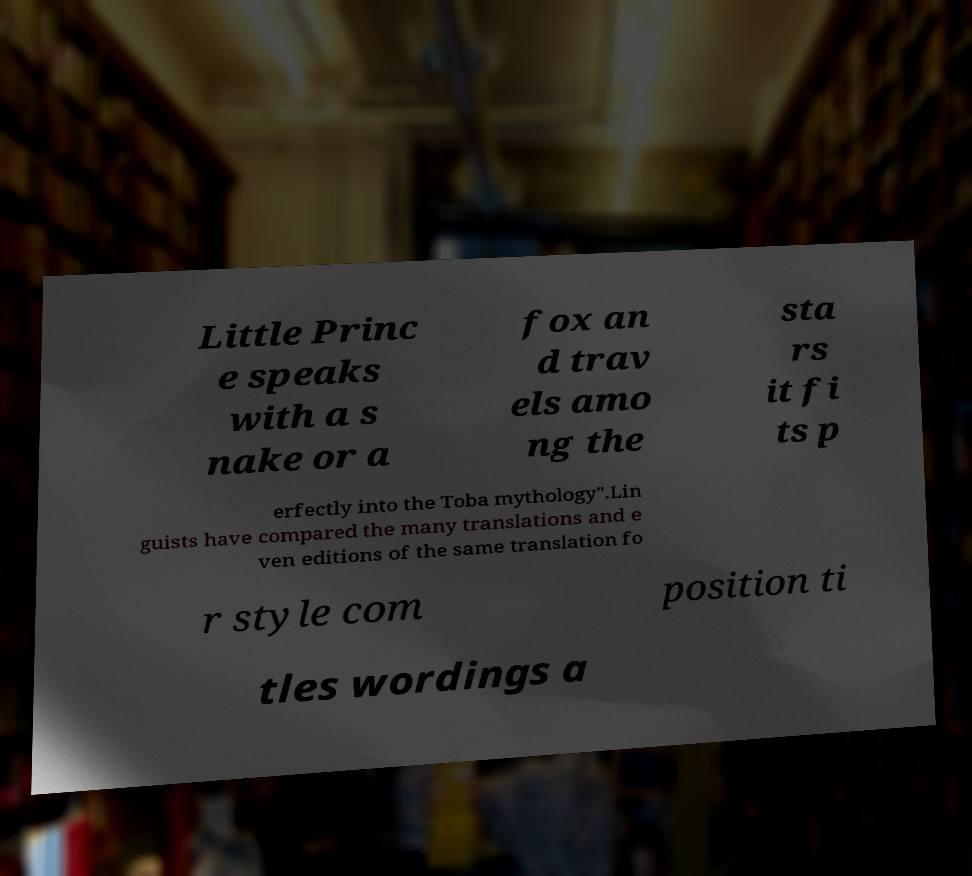What messages or text are displayed in this image? I need them in a readable, typed format. Little Princ e speaks with a s nake or a fox an d trav els amo ng the sta rs it fi ts p erfectly into the Toba mythology".Lin guists have compared the many translations and e ven editions of the same translation fo r style com position ti tles wordings a 